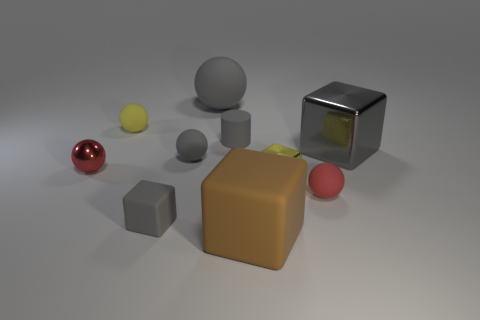What number of matte objects are large purple cylinders or gray things?
Give a very brief answer. 4. Are there any small matte spheres in front of the large block that is behind the big object that is in front of the tiny gray rubber block?
Offer a terse response. Yes. There is a yellow sphere that is the same material as the large brown thing; what size is it?
Offer a terse response. Small. There is a yellow metallic object; are there any gray matte objects on the right side of it?
Make the answer very short. No. There is a tiny yellow object that is on the right side of the large gray rubber ball; is there a small red metal object on the right side of it?
Give a very brief answer. No. There is a cylinder behind the large gray metallic object; is it the same size as the gray rubber ball in front of the gray metallic block?
Provide a succinct answer. Yes. How many big things are either cyan things or yellow matte balls?
Give a very brief answer. 0. What is the material of the object on the left side of the rubber thing to the left of the small matte cube?
Provide a short and direct response. Metal. There is a metallic object that is the same color as the tiny rubber cube; what is its shape?
Make the answer very short. Cube. Are there any blocks that have the same material as the brown object?
Offer a terse response. Yes. 